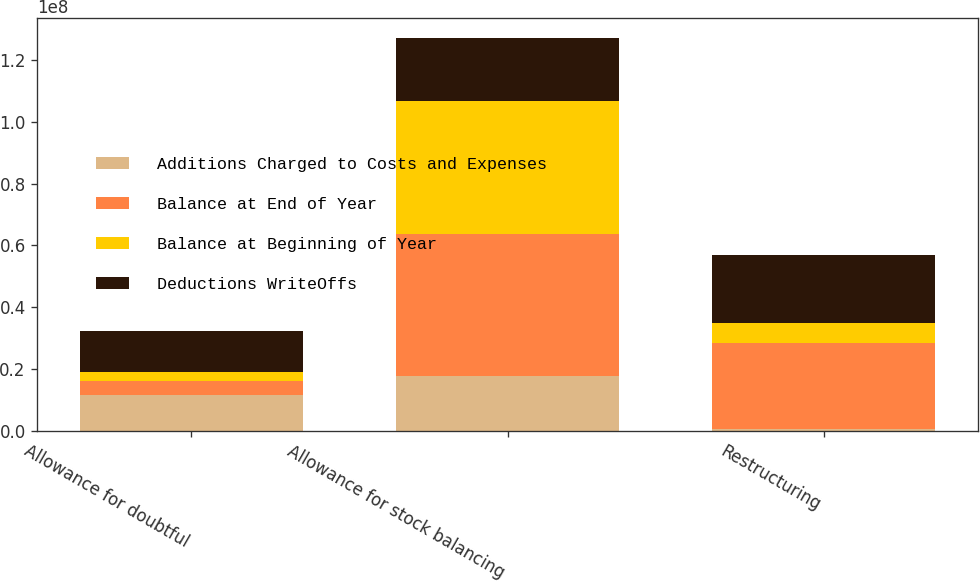<chart> <loc_0><loc_0><loc_500><loc_500><stacked_bar_chart><ecel><fcel>Allowance for doubtful<fcel>Allowance for stock balancing<fcel>Restructuring<nl><fcel>Additions Charged to Costs and Expenses<fcel>1.1611e+07<fcel>1.7761e+07<fcel>391000<nl><fcel>Balance at End of Year<fcel>4.519e+06<fcel>4.5876e+07<fcel>2.8097e+07<nl><fcel>Balance at Beginning of Year<fcel>2.949e+06<fcel>4.3059e+07<fcel>6.486e+06<nl><fcel>Deductions WriteOffs<fcel>1.3181e+07<fcel>2.0578e+07<fcel>2.2002e+07<nl></chart> 